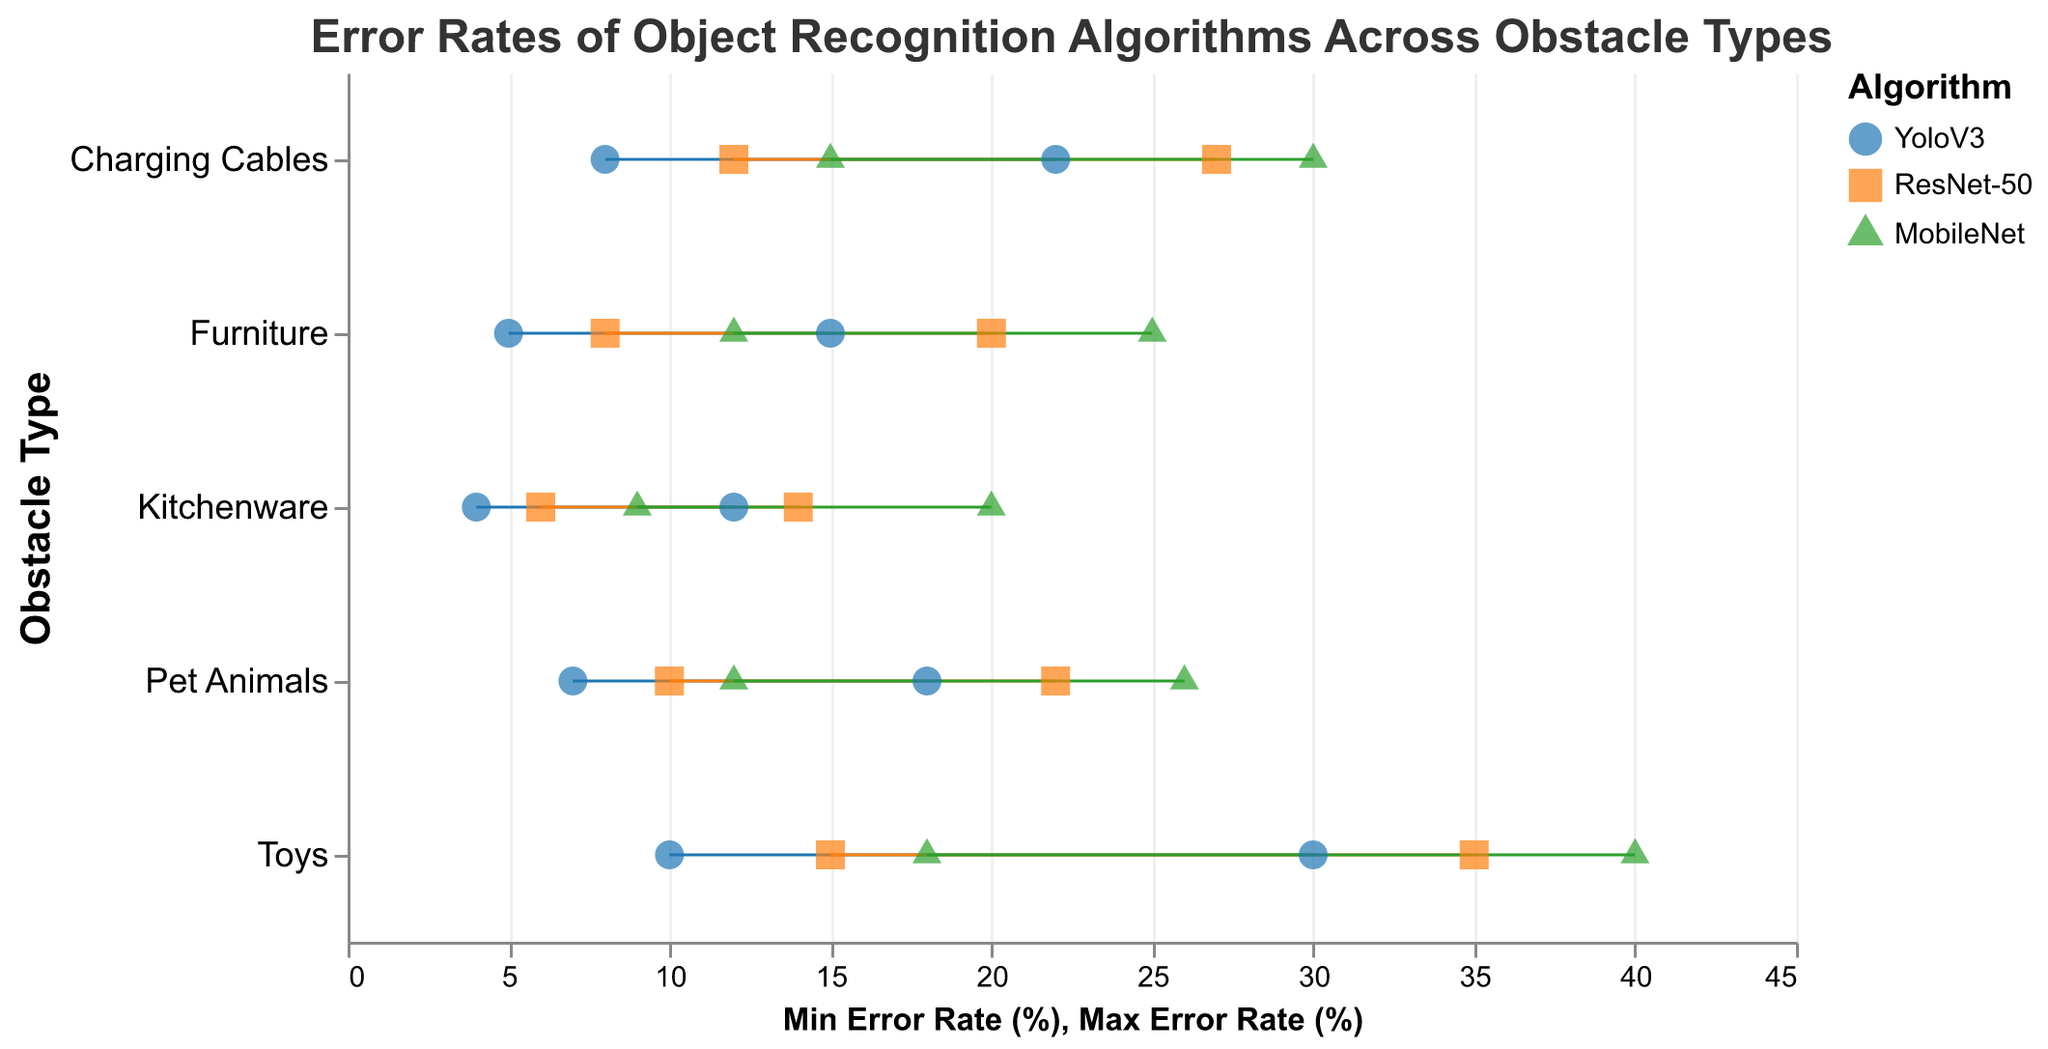What is the title of the plot? The title is displayed prominently at the top of the plot and reads "Error Rates of Object Recognition Algorithms Across Obstacle Types".
Answer: Error Rates of Object Recognition Algorithms Across Obstacle Types Which Obstacle Type has the lowest minimum error rate? By comparing the minimum error rates for all obstacle types, Kitchenware has the lowest minimum error rate at 4%.
Answer: Kitchenware Which algorithm has the highest maximum error rate for Toys? Looking at the range of error rates for Toys, MobileNet has the highest maximum error rate at 40%.
Answer: MobileNet What is the difference in the maximum error rates between YoloV3 and ResNet-50 for Pet Animals? The maximum error rate for YoloV3 is 18% and for ResNet-50 is 22%. The difference is 22% - 18% = 4%.
Answer: 4% How do the error rates for YoloV3 vary across different obstacle types? Error rates for YoloV3 vary as follows: Furniture (5%-15%), Toys (10%-30%), Kitchenware (4%-12%), Pet Animals (7%-18%), Charging Cables (8%-22%).
Answer: Varies from 4% to 30% Which algorithm has a consistently lower range of error rates across all obstacle types? Comparing the ranges across all obstacle types, YoloV3 has consistently lower ranges than ResNet-50 and MobileNet.
Answer: YoloV3 In which obstacle type does MobileNet exhibit the largest range in error rates? Calculate the range (Max-Min) for each type: Furniture (25%-12%=13), Toys (40%-18%=22), Kitchenware (20%-9%=11), Pet Animals (26%-12%=14), Charging Cables (30%-15%=15). Toys have the largest range of 22%.
Answer: Toys Compare the error ranges of Furniture for all three algorithms. Which algorithm has the smallest range and what is it? Calculate the range for each algorithm: YoloV3 (15%-5%=10%), ResNet-50 (20%-8%=12%), MobileNet (25%-12%=13%). YoloV3 has the smallest range of 10%.
Answer: YoloV3, 10% What is the average maximum error rate of the three algorithms for Charging Cables? Add the max error rates and divide by the number of algorithms: (22% + 27% + 30%) / 3 = 79% / 3 = 26.33%.
Answer: 26.33% Which obstacle type has the smallest maximum error rate for YoloV3? Look at the maximum error rates for YoloV3: Furniture (15%), Toys (30%), Kitchenware (12%), Pet Animals (18%), Charging Cables (22%). Kitchenware has the smallest maximum error rate at 12%.
Answer: Kitchenware 